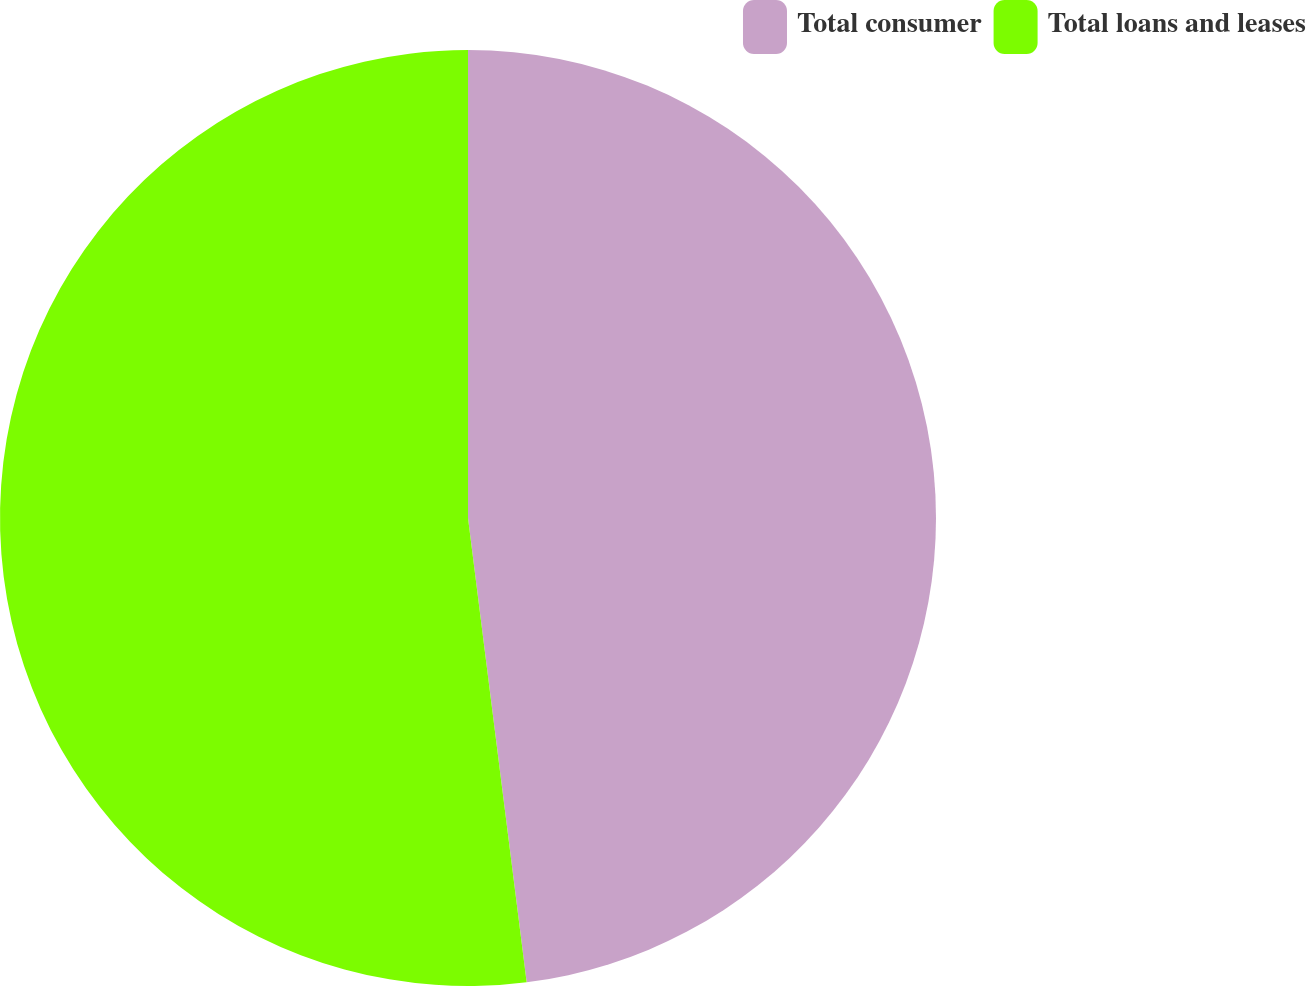Convert chart to OTSL. <chart><loc_0><loc_0><loc_500><loc_500><pie_chart><fcel>Total consumer<fcel>Total loans and leases<nl><fcel>48.0%<fcel>52.0%<nl></chart> 